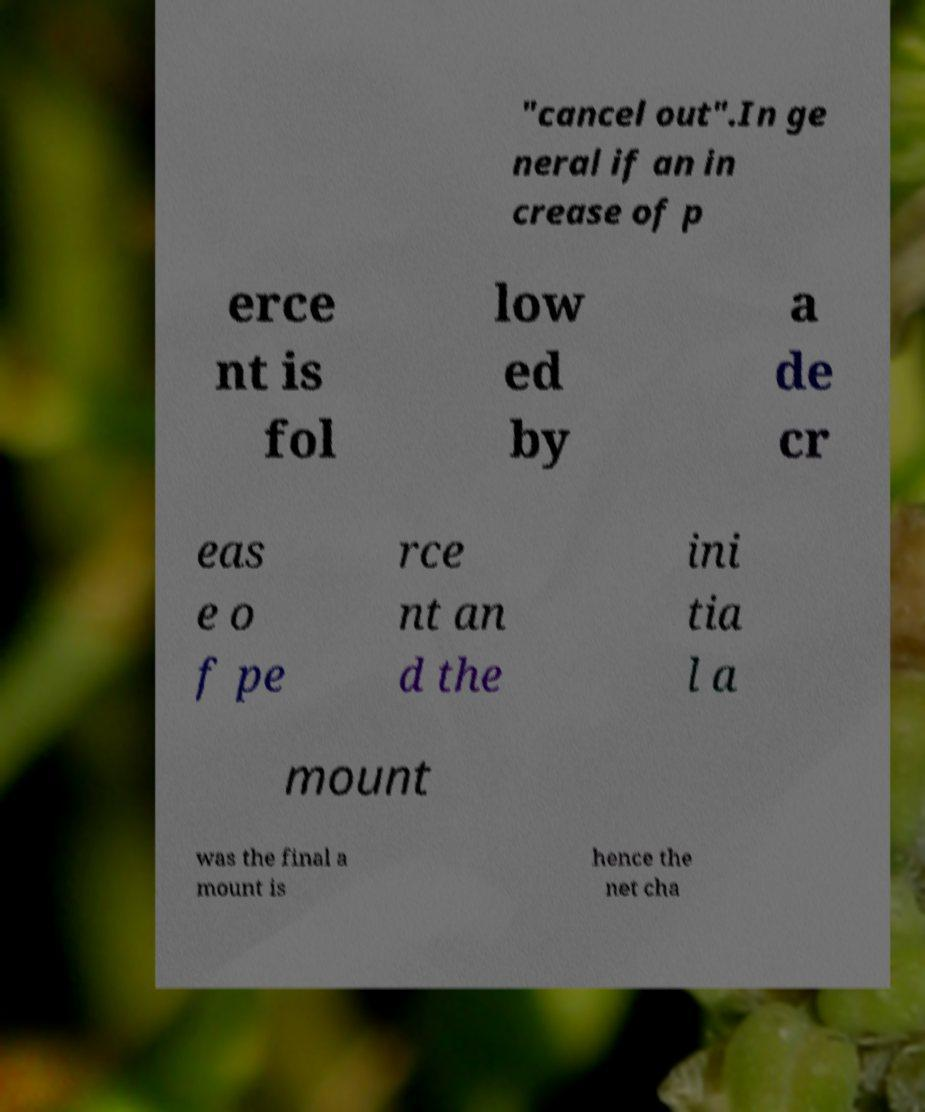There's text embedded in this image that I need extracted. Can you transcribe it verbatim? "cancel out".In ge neral if an in crease of p erce nt is fol low ed by a de cr eas e o f pe rce nt an d the ini tia l a mount was the final a mount is hence the net cha 